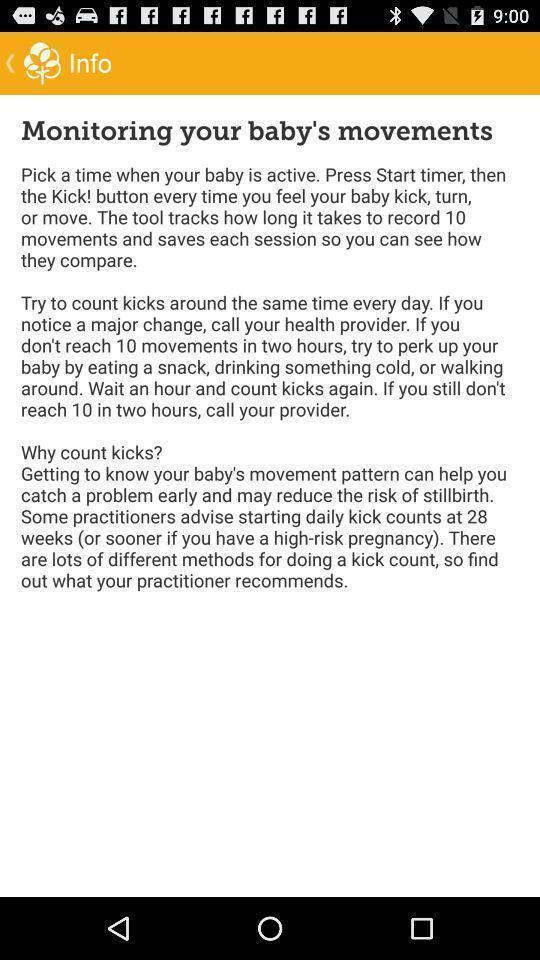Provide a description of this screenshot. Page displaying instructions for a babycare application. 